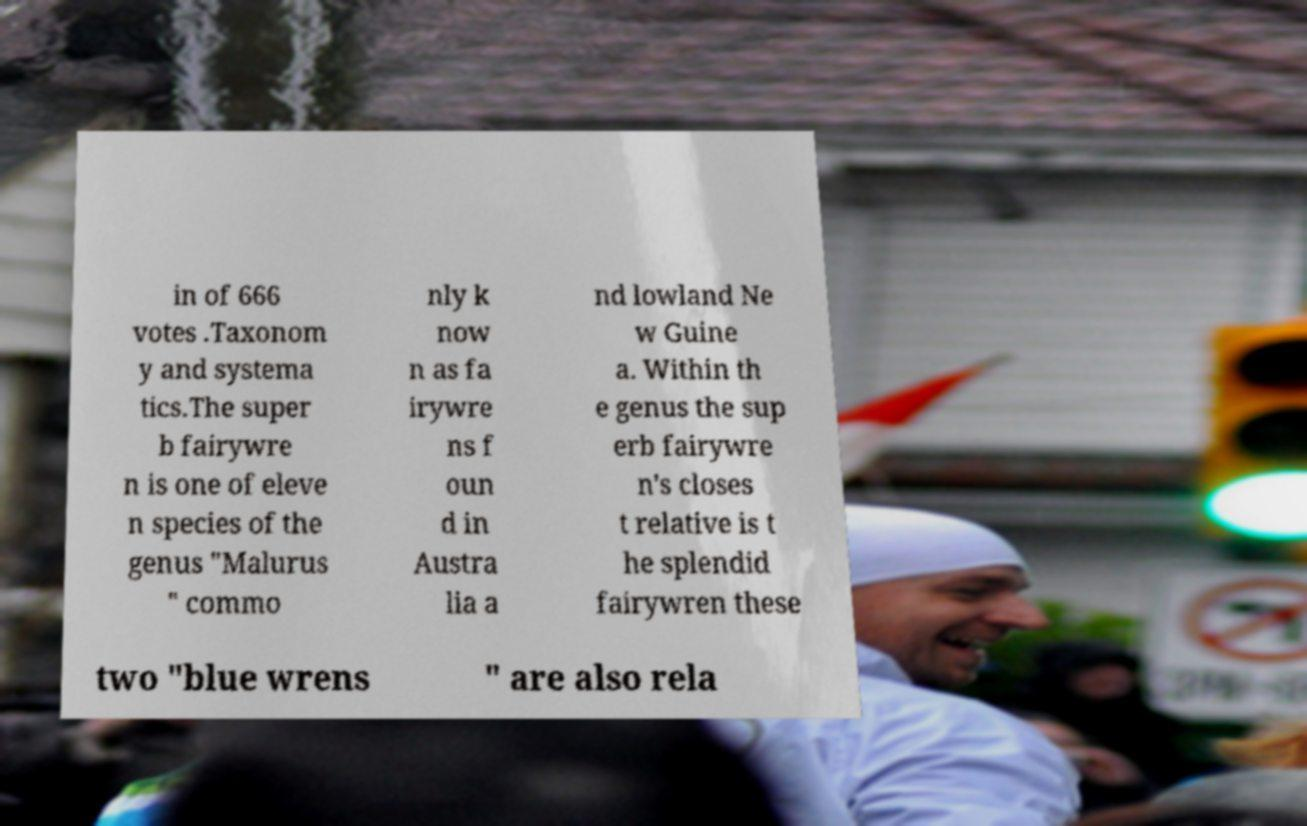Could you extract and type out the text from this image? in of 666 votes .Taxonom y and systema tics.The super b fairywre n is one of eleve n species of the genus "Malurus " commo nly k now n as fa irywre ns f oun d in Austra lia a nd lowland Ne w Guine a. Within th e genus the sup erb fairywre n's closes t relative is t he splendid fairywren these two "blue wrens " are also rela 